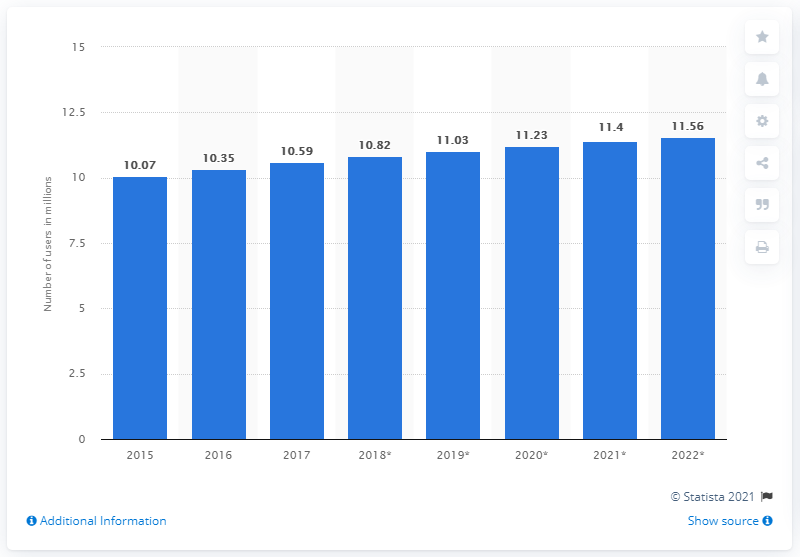Highlight a few significant elements in this photo. By 2022, it is projected that over 11.56 million Australians will have a Facebook account. 